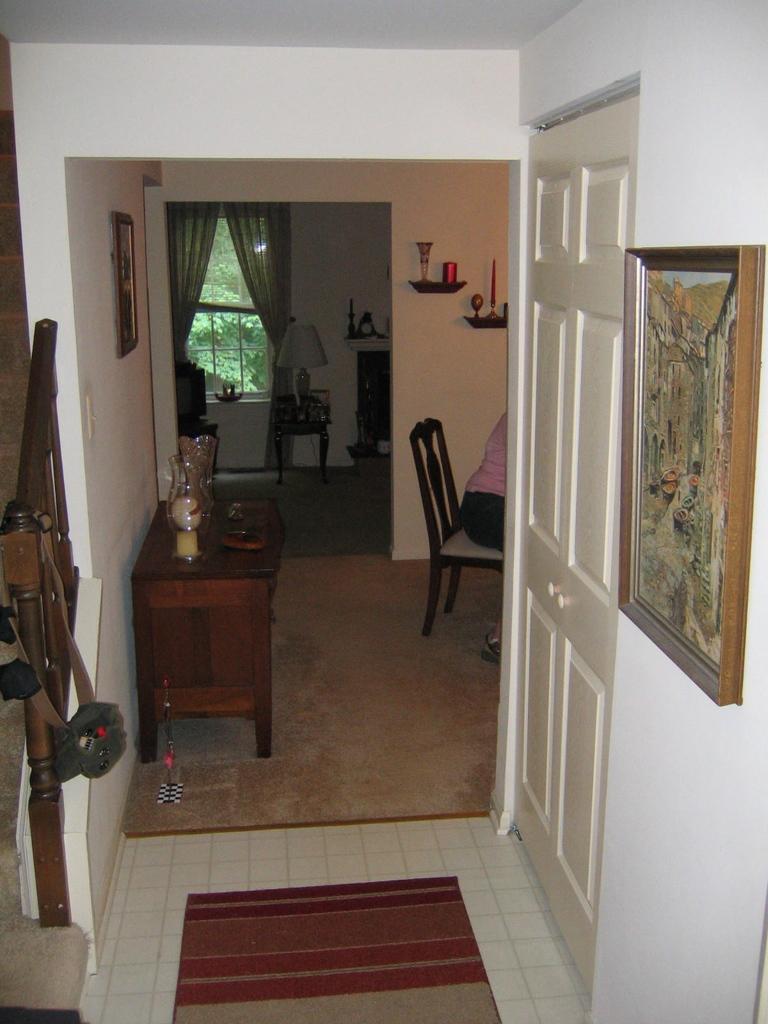Could you give a brief overview of what you see in this image? A corridor in a house is shown in the picture. There is a photo frame into wall. There is door beside. A woman is sitting in chair at a distance. There is a table with some items on it. There are some items on shelf. There is window with curtains in the background. 